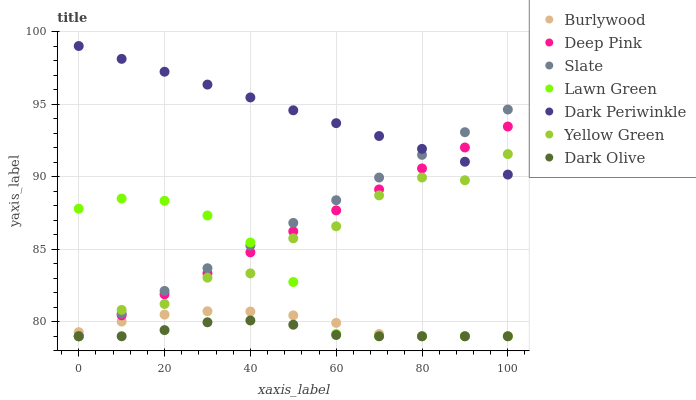Does Dark Olive have the minimum area under the curve?
Answer yes or no. Yes. Does Dark Periwinkle have the maximum area under the curve?
Answer yes or no. Yes. Does Deep Pink have the minimum area under the curve?
Answer yes or no. No. Does Deep Pink have the maximum area under the curve?
Answer yes or no. No. Is Dark Periwinkle the smoothest?
Answer yes or no. Yes. Is Yellow Green the roughest?
Answer yes or no. Yes. Is Deep Pink the smoothest?
Answer yes or no. No. Is Deep Pink the roughest?
Answer yes or no. No. Does Lawn Green have the lowest value?
Answer yes or no. Yes. Does Dark Periwinkle have the lowest value?
Answer yes or no. No. Does Dark Periwinkle have the highest value?
Answer yes or no. Yes. Does Deep Pink have the highest value?
Answer yes or no. No. Is Burlywood less than Dark Periwinkle?
Answer yes or no. Yes. Is Dark Periwinkle greater than Lawn Green?
Answer yes or no. Yes. Does Dark Olive intersect Yellow Green?
Answer yes or no. Yes. Is Dark Olive less than Yellow Green?
Answer yes or no. No. Is Dark Olive greater than Yellow Green?
Answer yes or no. No. Does Burlywood intersect Dark Periwinkle?
Answer yes or no. No. 